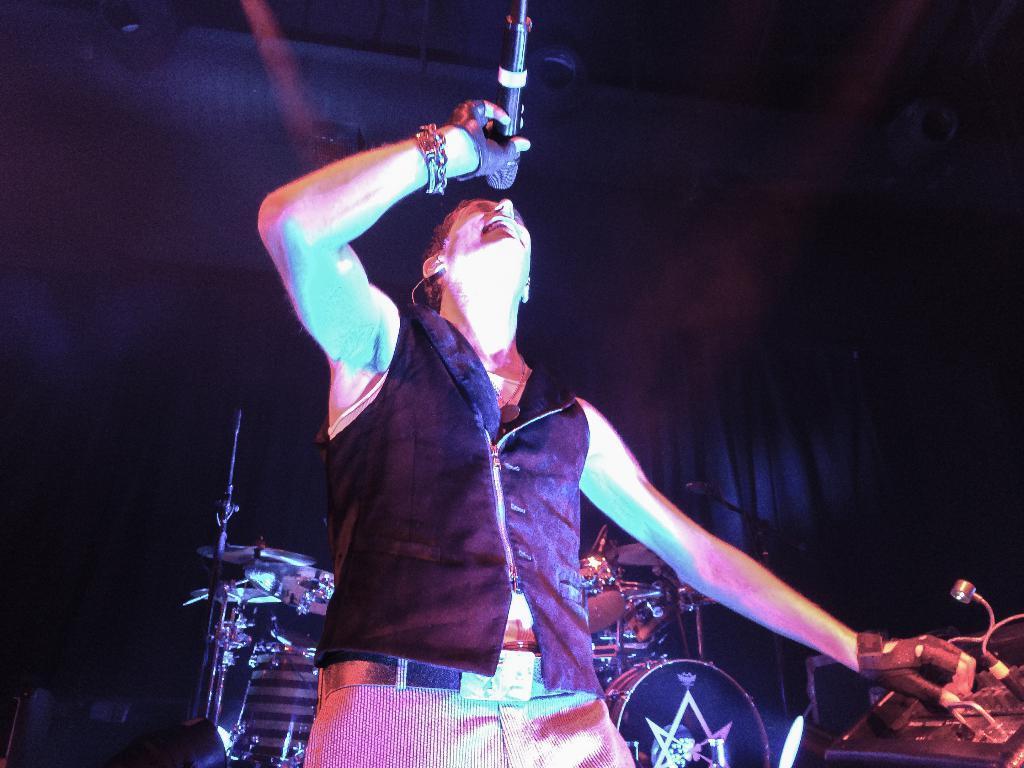How would you summarize this image in a sentence or two? In this image we can see a person holding a mic, he is singing, behind him there are drums, beside him there is an electronic object, there is a light and the background is dark. 